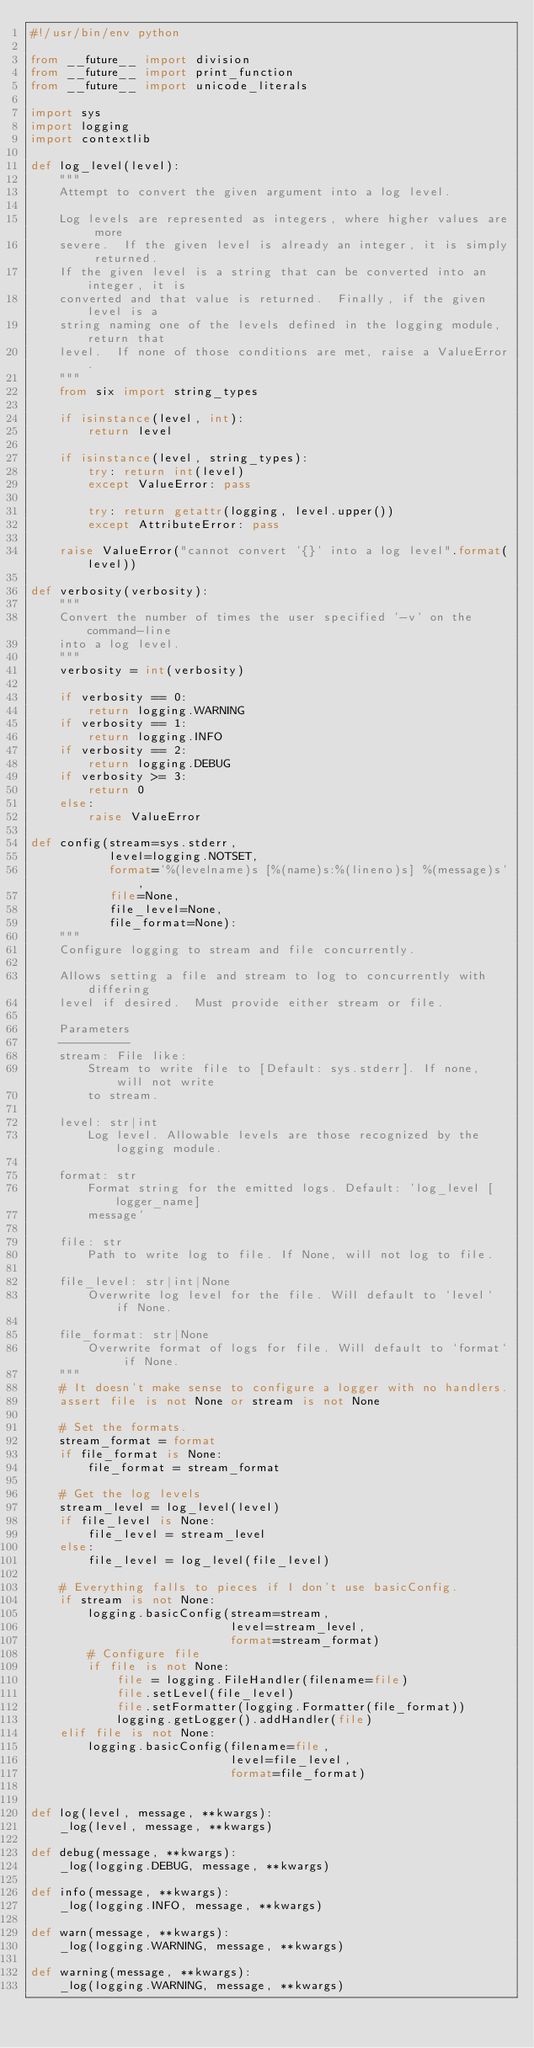Convert code to text. <code><loc_0><loc_0><loc_500><loc_500><_Python_>#!/usr/bin/env python

from __future__ import division
from __future__ import print_function
from __future__ import unicode_literals

import sys
import logging
import contextlib

def log_level(level):
    """
    Attempt to convert the given argument into a log level.

    Log levels are represented as integers, where higher values are more 
    severe.  If the given level is already an integer, it is simply returned.  
    If the given level is a string that can be converted into an integer, it is 
    converted and that value is returned.  Finally, if the given level is a 
    string naming one of the levels defined in the logging module, return that 
    level.  If none of those conditions are met, raise a ValueError.
    """
    from six import string_types

    if isinstance(level, int):
        return level

    if isinstance(level, string_types):
        try: return int(level)
        except ValueError: pass

        try: return getattr(logging, level.upper())
        except AttributeError: pass

    raise ValueError("cannot convert '{}' into a log level".format(level))

def verbosity(verbosity):
    """
    Convert the number of times the user specified '-v' on the command-line 
    into a log level.
    """
    verbosity = int(verbosity)

    if verbosity == 0:
        return logging.WARNING
    if verbosity == 1:
        return logging.INFO
    if verbosity == 2:
        return logging.DEBUG
    if verbosity >= 3:
        return 0
    else:
        raise ValueError

def config(stream=sys.stderr,
           level=logging.NOTSET,
           format='%(levelname)s [%(name)s:%(lineno)s] %(message)s',
           file=None,
           file_level=None,
           file_format=None):
    """
    Configure logging to stream and file concurrently.

    Allows setting a file and stream to log to concurrently with differing 
    level if desired.  Must provide either stream or file.

    Parameters
    ----------
    stream: File like:
        Stream to write file to [Default: sys.stderr]. If none, will not write 
        to stream.

    level: str|int
        Log level. Allowable levels are those recognized by the logging module.

    format: str
        Format string for the emitted logs. Default: 'log_level [logger_name] 
        message'

    file: str
        Path to write log to file. If None, will not log to file.

    file_level: str|int|None
        Overwrite log level for the file. Will default to `level` if None.

    file_format: str|None
        Overwrite format of logs for file. Will default to `format` if None.
    """
    # It doesn't make sense to configure a logger with no handlers.
    assert file is not None or stream is not None

    # Set the formats.
    stream_format = format
    if file_format is None:
        file_format = stream_format

    # Get the log levels
    stream_level = log_level(level)
    if file_level is None:
        file_level = stream_level
    else:
        file_level = log_level(file_level)

    # Everything falls to pieces if I don't use basicConfig.
    if stream is not None:
        logging.basicConfig(stream=stream,
                            level=stream_level,
                            format=stream_format)
        # Configure file
        if file is not None:
            file = logging.FileHandler(filename=file)
            file.setLevel(file_level)
            file.setFormatter(logging.Formatter(file_format))
            logging.getLogger().addHandler(file)
    elif file is not None:
        logging.basicConfig(filename=file,
                            level=file_level,
                            format=file_format)


def log(level, message, **kwargs):
    _log(level, message, **kwargs)

def debug(message, **kwargs):
    _log(logging.DEBUG, message, **kwargs)

def info(message, **kwargs):
    _log(logging.INFO, message, **kwargs)

def warn(message, **kwargs):
    _log(logging.WARNING, message, **kwargs)

def warning(message, **kwargs):
    _log(logging.WARNING, message, **kwargs)
</code> 